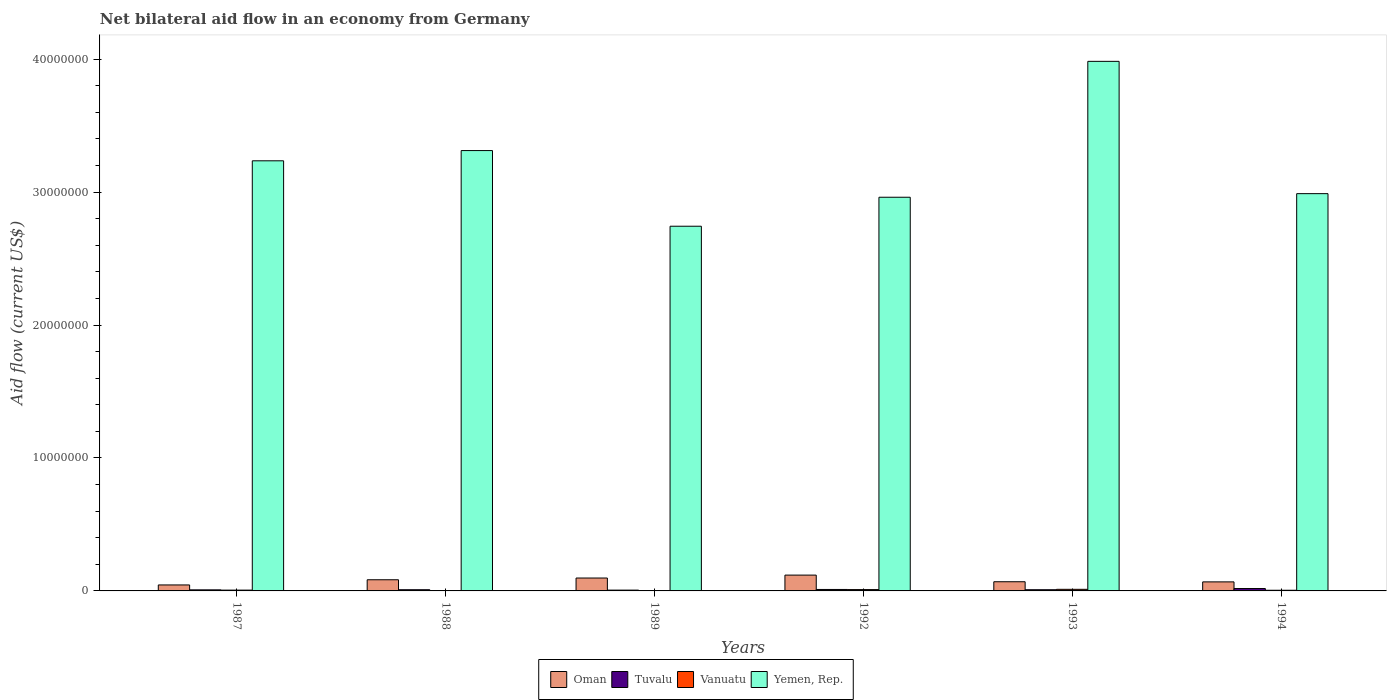How many different coloured bars are there?
Ensure brevity in your answer.  4. How many groups of bars are there?
Ensure brevity in your answer.  6. Are the number of bars per tick equal to the number of legend labels?
Provide a succinct answer. Yes. Are the number of bars on each tick of the X-axis equal?
Provide a short and direct response. Yes. How many bars are there on the 4th tick from the right?
Keep it short and to the point. 4. What is the net bilateral aid flow in Yemen, Rep. in 1994?
Provide a succinct answer. 2.99e+07. Across all years, what is the maximum net bilateral aid flow in Vanuatu?
Provide a succinct answer. 1.20e+05. Across all years, what is the minimum net bilateral aid flow in Tuvalu?
Your response must be concise. 6.00e+04. In which year was the net bilateral aid flow in Vanuatu minimum?
Your response must be concise. 1988. What is the total net bilateral aid flow in Oman in the graph?
Offer a very short reply. 4.82e+06. What is the difference between the net bilateral aid flow in Vanuatu in 1987 and that in 1992?
Your answer should be compact. -4.00e+04. What is the difference between the net bilateral aid flow in Yemen, Rep. in 1992 and the net bilateral aid flow in Tuvalu in 1988?
Provide a succinct answer. 2.95e+07. What is the average net bilateral aid flow in Yemen, Rep. per year?
Your answer should be compact. 3.20e+07. In the year 1993, what is the difference between the net bilateral aid flow in Yemen, Rep. and net bilateral aid flow in Oman?
Keep it short and to the point. 3.91e+07. In how many years, is the net bilateral aid flow in Yemen, Rep. greater than 22000000 US$?
Ensure brevity in your answer.  6. What is the ratio of the net bilateral aid flow in Vanuatu in 1992 to that in 1994?
Keep it short and to the point. 2. What is the difference between the highest and the lowest net bilateral aid flow in Vanuatu?
Provide a short and direct response. 1.10e+05. In how many years, is the net bilateral aid flow in Tuvalu greater than the average net bilateral aid flow in Tuvalu taken over all years?
Your answer should be compact. 2. Is the sum of the net bilateral aid flow in Vanuatu in 1988 and 1989 greater than the maximum net bilateral aid flow in Yemen, Rep. across all years?
Your response must be concise. No. What does the 2nd bar from the left in 1989 represents?
Provide a succinct answer. Tuvalu. What does the 2nd bar from the right in 1993 represents?
Offer a very short reply. Vanuatu. How many bars are there?
Offer a terse response. 24. Are all the bars in the graph horizontal?
Give a very brief answer. No. Are the values on the major ticks of Y-axis written in scientific E-notation?
Your answer should be compact. No. Does the graph contain any zero values?
Offer a terse response. No. Where does the legend appear in the graph?
Ensure brevity in your answer.  Bottom center. How many legend labels are there?
Provide a short and direct response. 4. How are the legend labels stacked?
Your answer should be very brief. Horizontal. What is the title of the graph?
Keep it short and to the point. Net bilateral aid flow in an economy from Germany. What is the Aid flow (current US$) of Oman in 1987?
Provide a succinct answer. 4.50e+05. What is the Aid flow (current US$) of Tuvalu in 1987?
Offer a terse response. 8.00e+04. What is the Aid flow (current US$) in Vanuatu in 1987?
Your answer should be compact. 6.00e+04. What is the Aid flow (current US$) in Yemen, Rep. in 1987?
Provide a succinct answer. 3.24e+07. What is the Aid flow (current US$) in Oman in 1988?
Your answer should be compact. 8.40e+05. What is the Aid flow (current US$) of Vanuatu in 1988?
Make the answer very short. 10000. What is the Aid flow (current US$) of Yemen, Rep. in 1988?
Ensure brevity in your answer.  3.31e+07. What is the Aid flow (current US$) of Oman in 1989?
Provide a succinct answer. 9.70e+05. What is the Aid flow (current US$) in Vanuatu in 1989?
Provide a succinct answer. 10000. What is the Aid flow (current US$) in Yemen, Rep. in 1989?
Ensure brevity in your answer.  2.74e+07. What is the Aid flow (current US$) in Oman in 1992?
Give a very brief answer. 1.19e+06. What is the Aid flow (current US$) of Vanuatu in 1992?
Offer a very short reply. 1.00e+05. What is the Aid flow (current US$) of Yemen, Rep. in 1992?
Give a very brief answer. 2.96e+07. What is the Aid flow (current US$) of Oman in 1993?
Give a very brief answer. 6.90e+05. What is the Aid flow (current US$) of Vanuatu in 1993?
Make the answer very short. 1.20e+05. What is the Aid flow (current US$) in Yemen, Rep. in 1993?
Your answer should be compact. 3.98e+07. What is the Aid flow (current US$) of Oman in 1994?
Your answer should be very brief. 6.80e+05. What is the Aid flow (current US$) of Yemen, Rep. in 1994?
Provide a short and direct response. 2.99e+07. Across all years, what is the maximum Aid flow (current US$) in Oman?
Offer a very short reply. 1.19e+06. Across all years, what is the maximum Aid flow (current US$) in Tuvalu?
Offer a terse response. 1.80e+05. Across all years, what is the maximum Aid flow (current US$) of Yemen, Rep.?
Offer a terse response. 3.98e+07. Across all years, what is the minimum Aid flow (current US$) in Yemen, Rep.?
Your response must be concise. 2.74e+07. What is the total Aid flow (current US$) of Oman in the graph?
Give a very brief answer. 4.82e+06. What is the total Aid flow (current US$) of Tuvalu in the graph?
Your answer should be very brief. 6.10e+05. What is the total Aid flow (current US$) of Yemen, Rep. in the graph?
Provide a succinct answer. 1.92e+08. What is the difference between the Aid flow (current US$) of Oman in 1987 and that in 1988?
Provide a short and direct response. -3.90e+05. What is the difference between the Aid flow (current US$) in Tuvalu in 1987 and that in 1988?
Provide a short and direct response. -10000. What is the difference between the Aid flow (current US$) of Vanuatu in 1987 and that in 1988?
Give a very brief answer. 5.00e+04. What is the difference between the Aid flow (current US$) of Yemen, Rep. in 1987 and that in 1988?
Offer a very short reply. -7.70e+05. What is the difference between the Aid flow (current US$) in Oman in 1987 and that in 1989?
Your response must be concise. -5.20e+05. What is the difference between the Aid flow (current US$) in Yemen, Rep. in 1987 and that in 1989?
Provide a succinct answer. 4.92e+06. What is the difference between the Aid flow (current US$) of Oman in 1987 and that in 1992?
Your response must be concise. -7.40e+05. What is the difference between the Aid flow (current US$) of Tuvalu in 1987 and that in 1992?
Offer a very short reply. -3.00e+04. What is the difference between the Aid flow (current US$) in Vanuatu in 1987 and that in 1992?
Make the answer very short. -4.00e+04. What is the difference between the Aid flow (current US$) of Yemen, Rep. in 1987 and that in 1992?
Ensure brevity in your answer.  2.74e+06. What is the difference between the Aid flow (current US$) in Oman in 1987 and that in 1993?
Give a very brief answer. -2.40e+05. What is the difference between the Aid flow (current US$) of Yemen, Rep. in 1987 and that in 1993?
Your answer should be compact. -7.48e+06. What is the difference between the Aid flow (current US$) of Vanuatu in 1987 and that in 1994?
Keep it short and to the point. 10000. What is the difference between the Aid flow (current US$) of Yemen, Rep. in 1987 and that in 1994?
Your answer should be compact. 2.47e+06. What is the difference between the Aid flow (current US$) in Oman in 1988 and that in 1989?
Ensure brevity in your answer.  -1.30e+05. What is the difference between the Aid flow (current US$) in Tuvalu in 1988 and that in 1989?
Offer a terse response. 3.00e+04. What is the difference between the Aid flow (current US$) in Yemen, Rep. in 1988 and that in 1989?
Provide a short and direct response. 5.69e+06. What is the difference between the Aid flow (current US$) in Oman in 1988 and that in 1992?
Offer a terse response. -3.50e+05. What is the difference between the Aid flow (current US$) of Tuvalu in 1988 and that in 1992?
Ensure brevity in your answer.  -2.00e+04. What is the difference between the Aid flow (current US$) in Yemen, Rep. in 1988 and that in 1992?
Provide a succinct answer. 3.51e+06. What is the difference between the Aid flow (current US$) of Tuvalu in 1988 and that in 1993?
Your response must be concise. 0. What is the difference between the Aid flow (current US$) of Yemen, Rep. in 1988 and that in 1993?
Provide a short and direct response. -6.71e+06. What is the difference between the Aid flow (current US$) in Oman in 1988 and that in 1994?
Keep it short and to the point. 1.60e+05. What is the difference between the Aid flow (current US$) of Tuvalu in 1988 and that in 1994?
Ensure brevity in your answer.  -9.00e+04. What is the difference between the Aid flow (current US$) in Yemen, Rep. in 1988 and that in 1994?
Your answer should be compact. 3.24e+06. What is the difference between the Aid flow (current US$) in Oman in 1989 and that in 1992?
Provide a succinct answer. -2.20e+05. What is the difference between the Aid flow (current US$) in Vanuatu in 1989 and that in 1992?
Your response must be concise. -9.00e+04. What is the difference between the Aid flow (current US$) in Yemen, Rep. in 1989 and that in 1992?
Offer a very short reply. -2.18e+06. What is the difference between the Aid flow (current US$) of Oman in 1989 and that in 1993?
Offer a terse response. 2.80e+05. What is the difference between the Aid flow (current US$) in Yemen, Rep. in 1989 and that in 1993?
Your answer should be very brief. -1.24e+07. What is the difference between the Aid flow (current US$) in Tuvalu in 1989 and that in 1994?
Your response must be concise. -1.20e+05. What is the difference between the Aid flow (current US$) of Yemen, Rep. in 1989 and that in 1994?
Your answer should be very brief. -2.45e+06. What is the difference between the Aid flow (current US$) in Tuvalu in 1992 and that in 1993?
Ensure brevity in your answer.  2.00e+04. What is the difference between the Aid flow (current US$) of Vanuatu in 1992 and that in 1993?
Provide a short and direct response. -2.00e+04. What is the difference between the Aid flow (current US$) in Yemen, Rep. in 1992 and that in 1993?
Offer a terse response. -1.02e+07. What is the difference between the Aid flow (current US$) in Oman in 1992 and that in 1994?
Offer a very short reply. 5.10e+05. What is the difference between the Aid flow (current US$) in Tuvalu in 1992 and that in 1994?
Make the answer very short. -7.00e+04. What is the difference between the Aid flow (current US$) in Vanuatu in 1992 and that in 1994?
Offer a very short reply. 5.00e+04. What is the difference between the Aid flow (current US$) of Yemen, Rep. in 1992 and that in 1994?
Make the answer very short. -2.70e+05. What is the difference between the Aid flow (current US$) of Yemen, Rep. in 1993 and that in 1994?
Give a very brief answer. 9.95e+06. What is the difference between the Aid flow (current US$) of Oman in 1987 and the Aid flow (current US$) of Tuvalu in 1988?
Offer a very short reply. 3.60e+05. What is the difference between the Aid flow (current US$) of Oman in 1987 and the Aid flow (current US$) of Yemen, Rep. in 1988?
Ensure brevity in your answer.  -3.27e+07. What is the difference between the Aid flow (current US$) in Tuvalu in 1987 and the Aid flow (current US$) in Yemen, Rep. in 1988?
Give a very brief answer. -3.30e+07. What is the difference between the Aid flow (current US$) in Vanuatu in 1987 and the Aid flow (current US$) in Yemen, Rep. in 1988?
Make the answer very short. -3.31e+07. What is the difference between the Aid flow (current US$) in Oman in 1987 and the Aid flow (current US$) in Tuvalu in 1989?
Ensure brevity in your answer.  3.90e+05. What is the difference between the Aid flow (current US$) of Oman in 1987 and the Aid flow (current US$) of Vanuatu in 1989?
Your answer should be compact. 4.40e+05. What is the difference between the Aid flow (current US$) of Oman in 1987 and the Aid flow (current US$) of Yemen, Rep. in 1989?
Provide a succinct answer. -2.70e+07. What is the difference between the Aid flow (current US$) of Tuvalu in 1987 and the Aid flow (current US$) of Yemen, Rep. in 1989?
Offer a terse response. -2.74e+07. What is the difference between the Aid flow (current US$) of Vanuatu in 1987 and the Aid flow (current US$) of Yemen, Rep. in 1989?
Make the answer very short. -2.74e+07. What is the difference between the Aid flow (current US$) of Oman in 1987 and the Aid flow (current US$) of Yemen, Rep. in 1992?
Offer a very short reply. -2.92e+07. What is the difference between the Aid flow (current US$) of Tuvalu in 1987 and the Aid flow (current US$) of Vanuatu in 1992?
Provide a succinct answer. -2.00e+04. What is the difference between the Aid flow (current US$) of Tuvalu in 1987 and the Aid flow (current US$) of Yemen, Rep. in 1992?
Ensure brevity in your answer.  -2.95e+07. What is the difference between the Aid flow (current US$) of Vanuatu in 1987 and the Aid flow (current US$) of Yemen, Rep. in 1992?
Your answer should be very brief. -2.96e+07. What is the difference between the Aid flow (current US$) of Oman in 1987 and the Aid flow (current US$) of Tuvalu in 1993?
Offer a terse response. 3.60e+05. What is the difference between the Aid flow (current US$) in Oman in 1987 and the Aid flow (current US$) in Vanuatu in 1993?
Your answer should be very brief. 3.30e+05. What is the difference between the Aid flow (current US$) of Oman in 1987 and the Aid flow (current US$) of Yemen, Rep. in 1993?
Keep it short and to the point. -3.94e+07. What is the difference between the Aid flow (current US$) of Tuvalu in 1987 and the Aid flow (current US$) of Vanuatu in 1993?
Provide a short and direct response. -4.00e+04. What is the difference between the Aid flow (current US$) in Tuvalu in 1987 and the Aid flow (current US$) in Yemen, Rep. in 1993?
Your answer should be very brief. -3.98e+07. What is the difference between the Aid flow (current US$) of Vanuatu in 1987 and the Aid flow (current US$) of Yemen, Rep. in 1993?
Offer a very short reply. -3.98e+07. What is the difference between the Aid flow (current US$) of Oman in 1987 and the Aid flow (current US$) of Tuvalu in 1994?
Offer a very short reply. 2.70e+05. What is the difference between the Aid flow (current US$) of Oman in 1987 and the Aid flow (current US$) of Yemen, Rep. in 1994?
Provide a succinct answer. -2.94e+07. What is the difference between the Aid flow (current US$) of Tuvalu in 1987 and the Aid flow (current US$) of Yemen, Rep. in 1994?
Give a very brief answer. -2.98e+07. What is the difference between the Aid flow (current US$) of Vanuatu in 1987 and the Aid flow (current US$) of Yemen, Rep. in 1994?
Offer a very short reply. -2.98e+07. What is the difference between the Aid flow (current US$) in Oman in 1988 and the Aid flow (current US$) in Tuvalu in 1989?
Provide a short and direct response. 7.80e+05. What is the difference between the Aid flow (current US$) in Oman in 1988 and the Aid flow (current US$) in Vanuatu in 1989?
Ensure brevity in your answer.  8.30e+05. What is the difference between the Aid flow (current US$) of Oman in 1988 and the Aid flow (current US$) of Yemen, Rep. in 1989?
Provide a short and direct response. -2.66e+07. What is the difference between the Aid flow (current US$) of Tuvalu in 1988 and the Aid flow (current US$) of Vanuatu in 1989?
Make the answer very short. 8.00e+04. What is the difference between the Aid flow (current US$) in Tuvalu in 1988 and the Aid flow (current US$) in Yemen, Rep. in 1989?
Make the answer very short. -2.73e+07. What is the difference between the Aid flow (current US$) in Vanuatu in 1988 and the Aid flow (current US$) in Yemen, Rep. in 1989?
Give a very brief answer. -2.74e+07. What is the difference between the Aid flow (current US$) of Oman in 1988 and the Aid flow (current US$) of Tuvalu in 1992?
Your response must be concise. 7.30e+05. What is the difference between the Aid flow (current US$) in Oman in 1988 and the Aid flow (current US$) in Vanuatu in 1992?
Make the answer very short. 7.40e+05. What is the difference between the Aid flow (current US$) in Oman in 1988 and the Aid flow (current US$) in Yemen, Rep. in 1992?
Offer a very short reply. -2.88e+07. What is the difference between the Aid flow (current US$) of Tuvalu in 1988 and the Aid flow (current US$) of Vanuatu in 1992?
Keep it short and to the point. -10000. What is the difference between the Aid flow (current US$) in Tuvalu in 1988 and the Aid flow (current US$) in Yemen, Rep. in 1992?
Offer a very short reply. -2.95e+07. What is the difference between the Aid flow (current US$) in Vanuatu in 1988 and the Aid flow (current US$) in Yemen, Rep. in 1992?
Provide a short and direct response. -2.96e+07. What is the difference between the Aid flow (current US$) of Oman in 1988 and the Aid flow (current US$) of Tuvalu in 1993?
Your answer should be compact. 7.50e+05. What is the difference between the Aid flow (current US$) of Oman in 1988 and the Aid flow (current US$) of Vanuatu in 1993?
Make the answer very short. 7.20e+05. What is the difference between the Aid flow (current US$) of Oman in 1988 and the Aid flow (current US$) of Yemen, Rep. in 1993?
Your answer should be very brief. -3.90e+07. What is the difference between the Aid flow (current US$) of Tuvalu in 1988 and the Aid flow (current US$) of Vanuatu in 1993?
Give a very brief answer. -3.00e+04. What is the difference between the Aid flow (current US$) in Tuvalu in 1988 and the Aid flow (current US$) in Yemen, Rep. in 1993?
Ensure brevity in your answer.  -3.97e+07. What is the difference between the Aid flow (current US$) in Vanuatu in 1988 and the Aid flow (current US$) in Yemen, Rep. in 1993?
Provide a short and direct response. -3.98e+07. What is the difference between the Aid flow (current US$) in Oman in 1988 and the Aid flow (current US$) in Tuvalu in 1994?
Provide a succinct answer. 6.60e+05. What is the difference between the Aid flow (current US$) of Oman in 1988 and the Aid flow (current US$) of Vanuatu in 1994?
Provide a succinct answer. 7.90e+05. What is the difference between the Aid flow (current US$) of Oman in 1988 and the Aid flow (current US$) of Yemen, Rep. in 1994?
Your answer should be very brief. -2.90e+07. What is the difference between the Aid flow (current US$) of Tuvalu in 1988 and the Aid flow (current US$) of Vanuatu in 1994?
Ensure brevity in your answer.  4.00e+04. What is the difference between the Aid flow (current US$) of Tuvalu in 1988 and the Aid flow (current US$) of Yemen, Rep. in 1994?
Give a very brief answer. -2.98e+07. What is the difference between the Aid flow (current US$) in Vanuatu in 1988 and the Aid flow (current US$) in Yemen, Rep. in 1994?
Provide a succinct answer. -2.99e+07. What is the difference between the Aid flow (current US$) of Oman in 1989 and the Aid flow (current US$) of Tuvalu in 1992?
Offer a terse response. 8.60e+05. What is the difference between the Aid flow (current US$) of Oman in 1989 and the Aid flow (current US$) of Vanuatu in 1992?
Keep it short and to the point. 8.70e+05. What is the difference between the Aid flow (current US$) in Oman in 1989 and the Aid flow (current US$) in Yemen, Rep. in 1992?
Give a very brief answer. -2.86e+07. What is the difference between the Aid flow (current US$) of Tuvalu in 1989 and the Aid flow (current US$) of Yemen, Rep. in 1992?
Offer a terse response. -2.96e+07. What is the difference between the Aid flow (current US$) in Vanuatu in 1989 and the Aid flow (current US$) in Yemen, Rep. in 1992?
Your answer should be compact. -2.96e+07. What is the difference between the Aid flow (current US$) of Oman in 1989 and the Aid flow (current US$) of Tuvalu in 1993?
Make the answer very short. 8.80e+05. What is the difference between the Aid flow (current US$) in Oman in 1989 and the Aid flow (current US$) in Vanuatu in 1993?
Offer a very short reply. 8.50e+05. What is the difference between the Aid flow (current US$) in Oman in 1989 and the Aid flow (current US$) in Yemen, Rep. in 1993?
Your answer should be compact. -3.89e+07. What is the difference between the Aid flow (current US$) of Tuvalu in 1989 and the Aid flow (current US$) of Vanuatu in 1993?
Provide a short and direct response. -6.00e+04. What is the difference between the Aid flow (current US$) of Tuvalu in 1989 and the Aid flow (current US$) of Yemen, Rep. in 1993?
Make the answer very short. -3.98e+07. What is the difference between the Aid flow (current US$) in Vanuatu in 1989 and the Aid flow (current US$) in Yemen, Rep. in 1993?
Keep it short and to the point. -3.98e+07. What is the difference between the Aid flow (current US$) of Oman in 1989 and the Aid flow (current US$) of Tuvalu in 1994?
Provide a short and direct response. 7.90e+05. What is the difference between the Aid flow (current US$) of Oman in 1989 and the Aid flow (current US$) of Vanuatu in 1994?
Your answer should be very brief. 9.20e+05. What is the difference between the Aid flow (current US$) in Oman in 1989 and the Aid flow (current US$) in Yemen, Rep. in 1994?
Offer a terse response. -2.89e+07. What is the difference between the Aid flow (current US$) in Tuvalu in 1989 and the Aid flow (current US$) in Yemen, Rep. in 1994?
Your answer should be very brief. -2.98e+07. What is the difference between the Aid flow (current US$) of Vanuatu in 1989 and the Aid flow (current US$) of Yemen, Rep. in 1994?
Your answer should be very brief. -2.99e+07. What is the difference between the Aid flow (current US$) of Oman in 1992 and the Aid flow (current US$) of Tuvalu in 1993?
Give a very brief answer. 1.10e+06. What is the difference between the Aid flow (current US$) of Oman in 1992 and the Aid flow (current US$) of Vanuatu in 1993?
Give a very brief answer. 1.07e+06. What is the difference between the Aid flow (current US$) in Oman in 1992 and the Aid flow (current US$) in Yemen, Rep. in 1993?
Provide a short and direct response. -3.86e+07. What is the difference between the Aid flow (current US$) of Tuvalu in 1992 and the Aid flow (current US$) of Yemen, Rep. in 1993?
Ensure brevity in your answer.  -3.97e+07. What is the difference between the Aid flow (current US$) in Vanuatu in 1992 and the Aid flow (current US$) in Yemen, Rep. in 1993?
Your answer should be compact. -3.97e+07. What is the difference between the Aid flow (current US$) in Oman in 1992 and the Aid flow (current US$) in Tuvalu in 1994?
Your response must be concise. 1.01e+06. What is the difference between the Aid flow (current US$) of Oman in 1992 and the Aid flow (current US$) of Vanuatu in 1994?
Give a very brief answer. 1.14e+06. What is the difference between the Aid flow (current US$) in Oman in 1992 and the Aid flow (current US$) in Yemen, Rep. in 1994?
Provide a succinct answer. -2.87e+07. What is the difference between the Aid flow (current US$) in Tuvalu in 1992 and the Aid flow (current US$) in Vanuatu in 1994?
Offer a very short reply. 6.00e+04. What is the difference between the Aid flow (current US$) in Tuvalu in 1992 and the Aid flow (current US$) in Yemen, Rep. in 1994?
Make the answer very short. -2.98e+07. What is the difference between the Aid flow (current US$) of Vanuatu in 1992 and the Aid flow (current US$) of Yemen, Rep. in 1994?
Make the answer very short. -2.98e+07. What is the difference between the Aid flow (current US$) in Oman in 1993 and the Aid flow (current US$) in Tuvalu in 1994?
Your answer should be compact. 5.10e+05. What is the difference between the Aid flow (current US$) of Oman in 1993 and the Aid flow (current US$) of Vanuatu in 1994?
Your answer should be compact. 6.40e+05. What is the difference between the Aid flow (current US$) in Oman in 1993 and the Aid flow (current US$) in Yemen, Rep. in 1994?
Your answer should be very brief. -2.92e+07. What is the difference between the Aid flow (current US$) of Tuvalu in 1993 and the Aid flow (current US$) of Vanuatu in 1994?
Your answer should be very brief. 4.00e+04. What is the difference between the Aid flow (current US$) of Tuvalu in 1993 and the Aid flow (current US$) of Yemen, Rep. in 1994?
Give a very brief answer. -2.98e+07. What is the difference between the Aid flow (current US$) of Vanuatu in 1993 and the Aid flow (current US$) of Yemen, Rep. in 1994?
Offer a very short reply. -2.98e+07. What is the average Aid flow (current US$) of Oman per year?
Keep it short and to the point. 8.03e+05. What is the average Aid flow (current US$) of Tuvalu per year?
Your response must be concise. 1.02e+05. What is the average Aid flow (current US$) in Vanuatu per year?
Offer a terse response. 5.83e+04. What is the average Aid flow (current US$) of Yemen, Rep. per year?
Ensure brevity in your answer.  3.20e+07. In the year 1987, what is the difference between the Aid flow (current US$) of Oman and Aid flow (current US$) of Tuvalu?
Ensure brevity in your answer.  3.70e+05. In the year 1987, what is the difference between the Aid flow (current US$) of Oman and Aid flow (current US$) of Vanuatu?
Provide a succinct answer. 3.90e+05. In the year 1987, what is the difference between the Aid flow (current US$) in Oman and Aid flow (current US$) in Yemen, Rep.?
Your answer should be very brief. -3.19e+07. In the year 1987, what is the difference between the Aid flow (current US$) of Tuvalu and Aid flow (current US$) of Yemen, Rep.?
Your response must be concise. -3.23e+07. In the year 1987, what is the difference between the Aid flow (current US$) of Vanuatu and Aid flow (current US$) of Yemen, Rep.?
Make the answer very short. -3.23e+07. In the year 1988, what is the difference between the Aid flow (current US$) of Oman and Aid flow (current US$) of Tuvalu?
Offer a terse response. 7.50e+05. In the year 1988, what is the difference between the Aid flow (current US$) of Oman and Aid flow (current US$) of Vanuatu?
Your response must be concise. 8.30e+05. In the year 1988, what is the difference between the Aid flow (current US$) of Oman and Aid flow (current US$) of Yemen, Rep.?
Offer a very short reply. -3.23e+07. In the year 1988, what is the difference between the Aid flow (current US$) in Tuvalu and Aid flow (current US$) in Vanuatu?
Offer a terse response. 8.00e+04. In the year 1988, what is the difference between the Aid flow (current US$) of Tuvalu and Aid flow (current US$) of Yemen, Rep.?
Your answer should be very brief. -3.30e+07. In the year 1988, what is the difference between the Aid flow (current US$) in Vanuatu and Aid flow (current US$) in Yemen, Rep.?
Make the answer very short. -3.31e+07. In the year 1989, what is the difference between the Aid flow (current US$) of Oman and Aid flow (current US$) of Tuvalu?
Offer a very short reply. 9.10e+05. In the year 1989, what is the difference between the Aid flow (current US$) of Oman and Aid flow (current US$) of Vanuatu?
Make the answer very short. 9.60e+05. In the year 1989, what is the difference between the Aid flow (current US$) in Oman and Aid flow (current US$) in Yemen, Rep.?
Make the answer very short. -2.65e+07. In the year 1989, what is the difference between the Aid flow (current US$) of Tuvalu and Aid flow (current US$) of Yemen, Rep.?
Give a very brief answer. -2.74e+07. In the year 1989, what is the difference between the Aid flow (current US$) in Vanuatu and Aid flow (current US$) in Yemen, Rep.?
Make the answer very short. -2.74e+07. In the year 1992, what is the difference between the Aid flow (current US$) in Oman and Aid flow (current US$) in Tuvalu?
Provide a short and direct response. 1.08e+06. In the year 1992, what is the difference between the Aid flow (current US$) in Oman and Aid flow (current US$) in Vanuatu?
Give a very brief answer. 1.09e+06. In the year 1992, what is the difference between the Aid flow (current US$) in Oman and Aid flow (current US$) in Yemen, Rep.?
Your response must be concise. -2.84e+07. In the year 1992, what is the difference between the Aid flow (current US$) in Tuvalu and Aid flow (current US$) in Vanuatu?
Offer a very short reply. 10000. In the year 1992, what is the difference between the Aid flow (current US$) in Tuvalu and Aid flow (current US$) in Yemen, Rep.?
Ensure brevity in your answer.  -2.95e+07. In the year 1992, what is the difference between the Aid flow (current US$) in Vanuatu and Aid flow (current US$) in Yemen, Rep.?
Keep it short and to the point. -2.95e+07. In the year 1993, what is the difference between the Aid flow (current US$) of Oman and Aid flow (current US$) of Tuvalu?
Make the answer very short. 6.00e+05. In the year 1993, what is the difference between the Aid flow (current US$) of Oman and Aid flow (current US$) of Vanuatu?
Your answer should be very brief. 5.70e+05. In the year 1993, what is the difference between the Aid flow (current US$) of Oman and Aid flow (current US$) of Yemen, Rep.?
Your answer should be compact. -3.91e+07. In the year 1993, what is the difference between the Aid flow (current US$) in Tuvalu and Aid flow (current US$) in Yemen, Rep.?
Your answer should be compact. -3.97e+07. In the year 1993, what is the difference between the Aid flow (current US$) of Vanuatu and Aid flow (current US$) of Yemen, Rep.?
Your answer should be compact. -3.97e+07. In the year 1994, what is the difference between the Aid flow (current US$) of Oman and Aid flow (current US$) of Vanuatu?
Keep it short and to the point. 6.30e+05. In the year 1994, what is the difference between the Aid flow (current US$) in Oman and Aid flow (current US$) in Yemen, Rep.?
Make the answer very short. -2.92e+07. In the year 1994, what is the difference between the Aid flow (current US$) of Tuvalu and Aid flow (current US$) of Yemen, Rep.?
Offer a very short reply. -2.97e+07. In the year 1994, what is the difference between the Aid flow (current US$) of Vanuatu and Aid flow (current US$) of Yemen, Rep.?
Give a very brief answer. -2.98e+07. What is the ratio of the Aid flow (current US$) of Oman in 1987 to that in 1988?
Keep it short and to the point. 0.54. What is the ratio of the Aid flow (current US$) in Vanuatu in 1987 to that in 1988?
Your response must be concise. 6. What is the ratio of the Aid flow (current US$) of Yemen, Rep. in 1987 to that in 1988?
Give a very brief answer. 0.98. What is the ratio of the Aid flow (current US$) in Oman in 1987 to that in 1989?
Offer a terse response. 0.46. What is the ratio of the Aid flow (current US$) in Tuvalu in 1987 to that in 1989?
Make the answer very short. 1.33. What is the ratio of the Aid flow (current US$) in Yemen, Rep. in 1987 to that in 1989?
Offer a very short reply. 1.18. What is the ratio of the Aid flow (current US$) in Oman in 1987 to that in 1992?
Your answer should be compact. 0.38. What is the ratio of the Aid flow (current US$) of Tuvalu in 1987 to that in 1992?
Your answer should be very brief. 0.73. What is the ratio of the Aid flow (current US$) in Yemen, Rep. in 1987 to that in 1992?
Offer a very short reply. 1.09. What is the ratio of the Aid flow (current US$) in Oman in 1987 to that in 1993?
Your answer should be compact. 0.65. What is the ratio of the Aid flow (current US$) in Vanuatu in 1987 to that in 1993?
Give a very brief answer. 0.5. What is the ratio of the Aid flow (current US$) of Yemen, Rep. in 1987 to that in 1993?
Provide a short and direct response. 0.81. What is the ratio of the Aid flow (current US$) in Oman in 1987 to that in 1994?
Your answer should be compact. 0.66. What is the ratio of the Aid flow (current US$) of Tuvalu in 1987 to that in 1994?
Provide a succinct answer. 0.44. What is the ratio of the Aid flow (current US$) in Yemen, Rep. in 1987 to that in 1994?
Keep it short and to the point. 1.08. What is the ratio of the Aid flow (current US$) of Oman in 1988 to that in 1989?
Your answer should be very brief. 0.87. What is the ratio of the Aid flow (current US$) of Yemen, Rep. in 1988 to that in 1989?
Your response must be concise. 1.21. What is the ratio of the Aid flow (current US$) of Oman in 1988 to that in 1992?
Make the answer very short. 0.71. What is the ratio of the Aid flow (current US$) of Tuvalu in 1988 to that in 1992?
Offer a terse response. 0.82. What is the ratio of the Aid flow (current US$) in Yemen, Rep. in 1988 to that in 1992?
Make the answer very short. 1.12. What is the ratio of the Aid flow (current US$) of Oman in 1988 to that in 1993?
Make the answer very short. 1.22. What is the ratio of the Aid flow (current US$) in Tuvalu in 1988 to that in 1993?
Ensure brevity in your answer.  1. What is the ratio of the Aid flow (current US$) of Vanuatu in 1988 to that in 1993?
Keep it short and to the point. 0.08. What is the ratio of the Aid flow (current US$) in Yemen, Rep. in 1988 to that in 1993?
Your response must be concise. 0.83. What is the ratio of the Aid flow (current US$) in Oman in 1988 to that in 1994?
Give a very brief answer. 1.24. What is the ratio of the Aid flow (current US$) in Vanuatu in 1988 to that in 1994?
Offer a terse response. 0.2. What is the ratio of the Aid flow (current US$) of Yemen, Rep. in 1988 to that in 1994?
Offer a terse response. 1.11. What is the ratio of the Aid flow (current US$) of Oman in 1989 to that in 1992?
Offer a very short reply. 0.82. What is the ratio of the Aid flow (current US$) in Tuvalu in 1989 to that in 1992?
Offer a very short reply. 0.55. What is the ratio of the Aid flow (current US$) of Vanuatu in 1989 to that in 1992?
Offer a very short reply. 0.1. What is the ratio of the Aid flow (current US$) in Yemen, Rep. in 1989 to that in 1992?
Your answer should be compact. 0.93. What is the ratio of the Aid flow (current US$) of Oman in 1989 to that in 1993?
Provide a short and direct response. 1.41. What is the ratio of the Aid flow (current US$) of Tuvalu in 1989 to that in 1993?
Make the answer very short. 0.67. What is the ratio of the Aid flow (current US$) of Vanuatu in 1989 to that in 1993?
Your response must be concise. 0.08. What is the ratio of the Aid flow (current US$) in Yemen, Rep. in 1989 to that in 1993?
Keep it short and to the point. 0.69. What is the ratio of the Aid flow (current US$) of Oman in 1989 to that in 1994?
Your answer should be compact. 1.43. What is the ratio of the Aid flow (current US$) of Vanuatu in 1989 to that in 1994?
Your answer should be very brief. 0.2. What is the ratio of the Aid flow (current US$) of Yemen, Rep. in 1989 to that in 1994?
Provide a short and direct response. 0.92. What is the ratio of the Aid flow (current US$) in Oman in 1992 to that in 1993?
Give a very brief answer. 1.72. What is the ratio of the Aid flow (current US$) in Tuvalu in 1992 to that in 1993?
Your answer should be very brief. 1.22. What is the ratio of the Aid flow (current US$) in Yemen, Rep. in 1992 to that in 1993?
Keep it short and to the point. 0.74. What is the ratio of the Aid flow (current US$) in Oman in 1992 to that in 1994?
Your answer should be very brief. 1.75. What is the ratio of the Aid flow (current US$) in Tuvalu in 1992 to that in 1994?
Make the answer very short. 0.61. What is the ratio of the Aid flow (current US$) of Oman in 1993 to that in 1994?
Offer a terse response. 1.01. What is the ratio of the Aid flow (current US$) of Tuvalu in 1993 to that in 1994?
Offer a terse response. 0.5. What is the ratio of the Aid flow (current US$) of Vanuatu in 1993 to that in 1994?
Give a very brief answer. 2.4. What is the ratio of the Aid flow (current US$) of Yemen, Rep. in 1993 to that in 1994?
Give a very brief answer. 1.33. What is the difference between the highest and the second highest Aid flow (current US$) of Oman?
Provide a short and direct response. 2.20e+05. What is the difference between the highest and the second highest Aid flow (current US$) of Yemen, Rep.?
Your answer should be compact. 6.71e+06. What is the difference between the highest and the lowest Aid flow (current US$) in Oman?
Your response must be concise. 7.40e+05. What is the difference between the highest and the lowest Aid flow (current US$) in Tuvalu?
Offer a very short reply. 1.20e+05. What is the difference between the highest and the lowest Aid flow (current US$) of Yemen, Rep.?
Ensure brevity in your answer.  1.24e+07. 